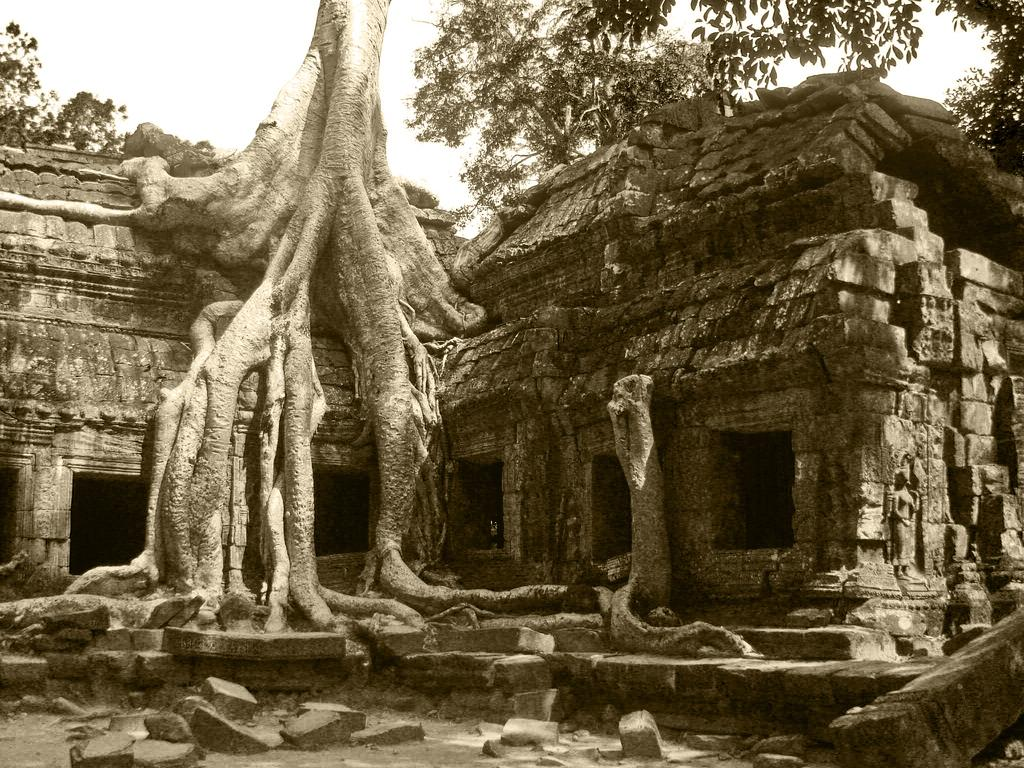What type of house is in the image? There is a stone house in the image. What is unique about the house? Tree roots are visible on the house. What is at the bottom of the image? There are stones at the bottom of the image. What is visible at the top of the image? The sky is visible at the top of the image. What type of vegetation can be seen in the image? Trees are visible in the image. How many kitties are playing with the cars in the image? There are no kitties or cars present in the image. What type of quiver is hanging on the tree in the image? There is no quiver present in the image; it features a stone house with tree roots and trees in the background. 